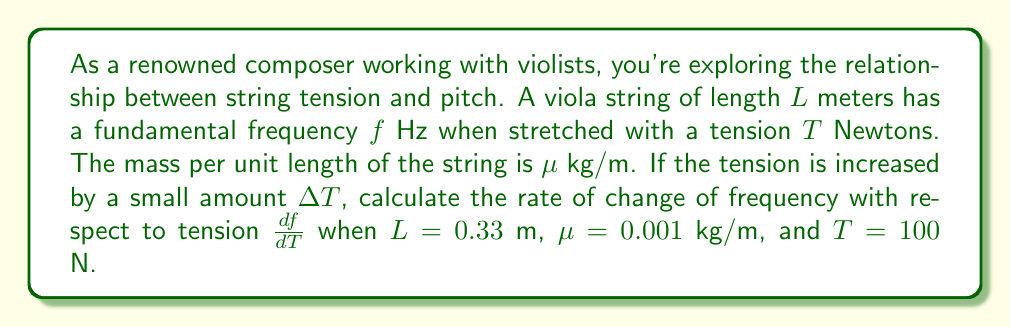Give your solution to this math problem. To solve this problem, we'll follow these steps:

1) First, recall the formula for the fundamental frequency of a vibrating string:

   $$f = \frac{1}{2L}\sqrt{\frac{T}{\mu}}$$

2) To find $\frac{df}{dT}$, we need to differentiate this equation with respect to $T$:

   $$\frac{df}{dT} = \frac{1}{2L} \cdot \frac{1}{2\sqrt{\frac{T}{\mu}}} \cdot \frac{1}{\mu}$$

3) Simplify this expression:

   $$\frac{df}{dT} = \frac{1}{4L\sqrt{\mu T}}$$

4) Now, we can substitute the given values:
   $L = 0.33$ m
   $\mu = 0.001$ kg/m
   $T = 100$ N

5) Plugging these into our equation:

   $$\frac{df}{dT} = \frac{1}{4 \cdot 0.33 \cdot \sqrt{0.001 \cdot 100}}$$

6) Simplify:

   $$\frac{df}{dT} = \frac{1}{1.32 \cdot \sqrt{0.1}} = \frac{1}{1.32 \cdot 0.3162} = 2.39$$

Therefore, the rate of change of frequency with respect to tension is approximately 2.39 Hz/N.
Answer: $\frac{df}{dT} \approx 2.39$ Hz/N 